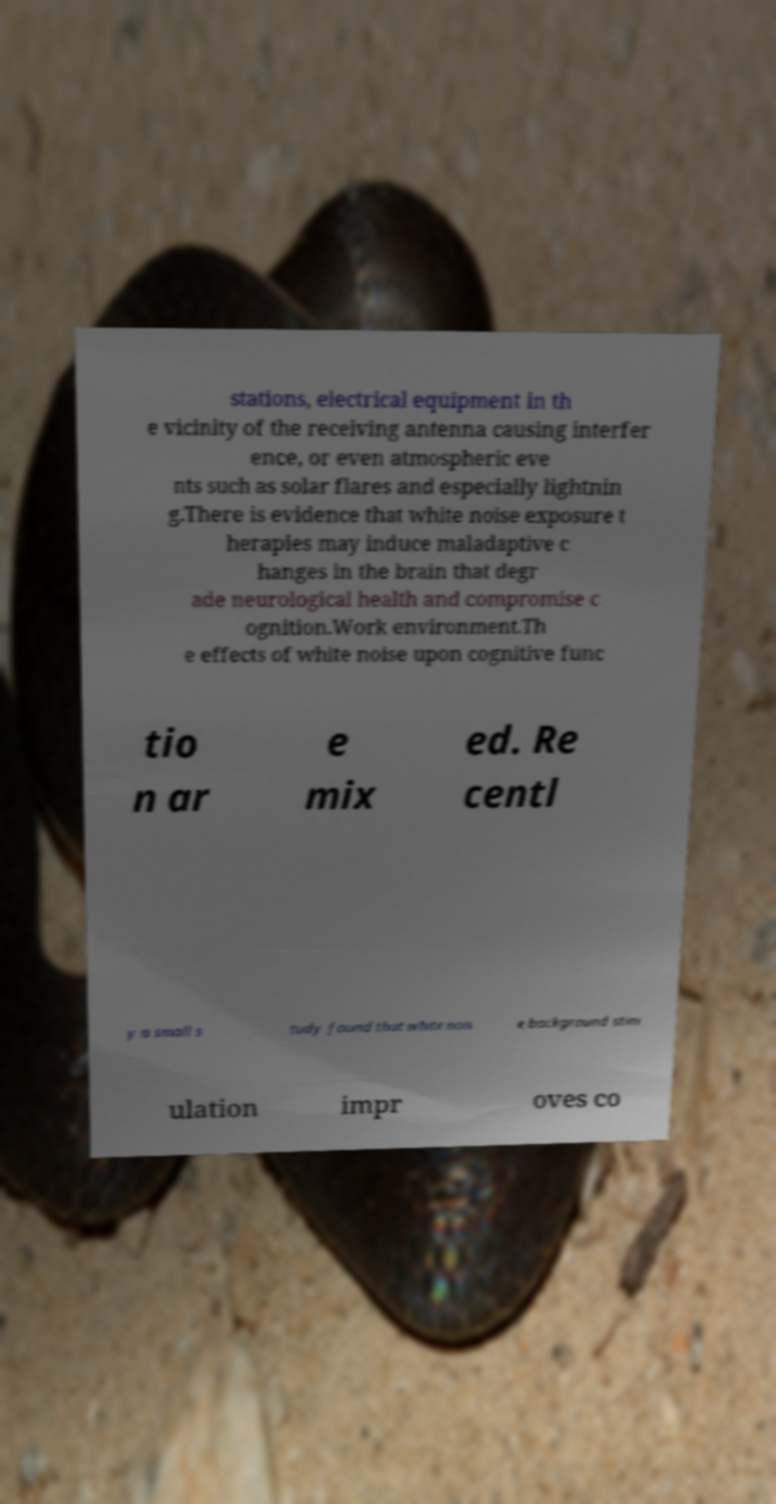Can you accurately transcribe the text from the provided image for me? stations, electrical equipment in th e vicinity of the receiving antenna causing interfer ence, or even atmospheric eve nts such as solar flares and especially lightnin g.There is evidence that white noise exposure t herapies may induce maladaptive c hanges in the brain that degr ade neurological health and compromise c ognition.Work environment.Th e effects of white noise upon cognitive func tio n ar e mix ed. Re centl y a small s tudy found that white nois e background stim ulation impr oves co 